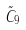Convert formula to latex. <formula><loc_0><loc_0><loc_500><loc_500>\tilde { C } _ { 9 }</formula> 